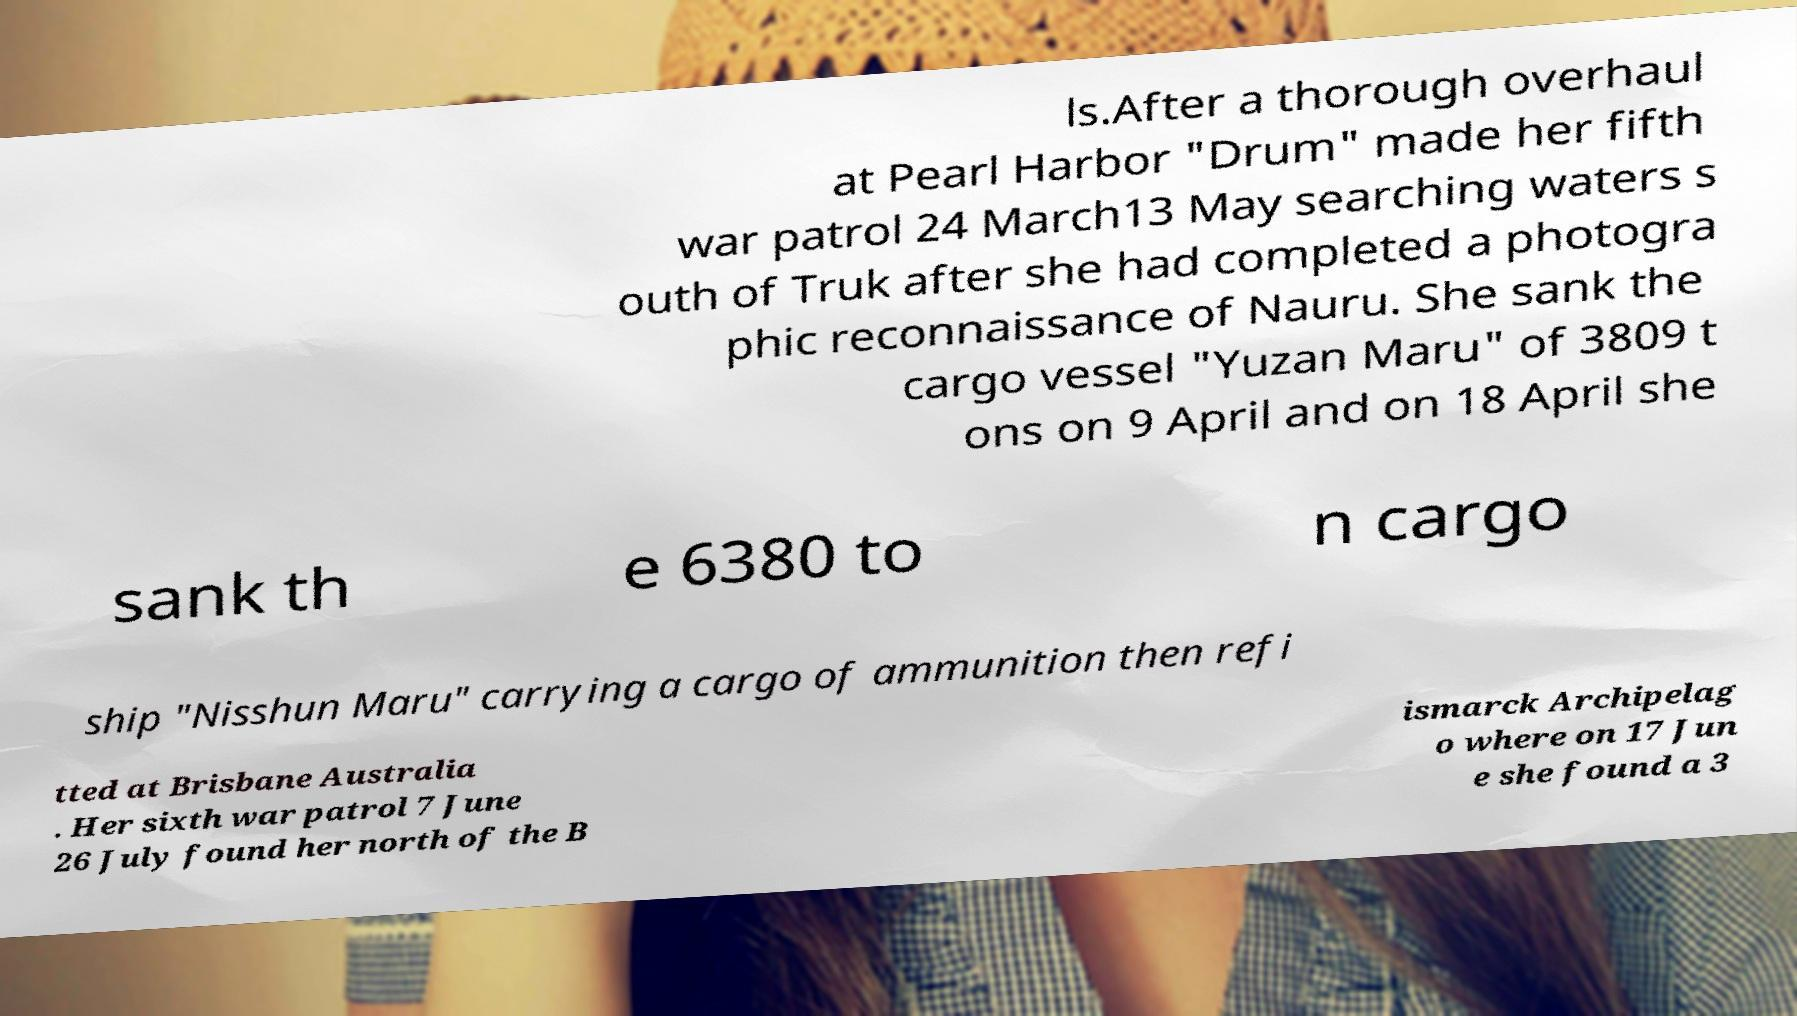Can you read and provide the text displayed in the image?This photo seems to have some interesting text. Can you extract and type it out for me? ls.After a thorough overhaul at Pearl Harbor "Drum" made her fifth war patrol 24 March13 May searching waters s outh of Truk after she had completed a photogra phic reconnaissance of Nauru. She sank the cargo vessel "Yuzan Maru" of 3809 t ons on 9 April and on 18 April she sank th e 6380 to n cargo ship "Nisshun Maru" carrying a cargo of ammunition then refi tted at Brisbane Australia . Her sixth war patrol 7 June 26 July found her north of the B ismarck Archipelag o where on 17 Jun e she found a 3 